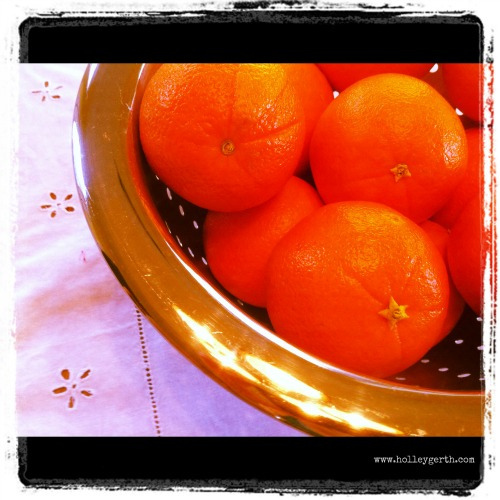<image>What is the netting holding the fruit made of? I don't know what the netting holding the fruit is made of. It could be copper, metal, cloth, or brass, or there might not be any netting at all. What is the netting holding the fruit made of? I don't know what the netting holding the fruit is made of. It can be made of copper, metal, cloth, or brass. 